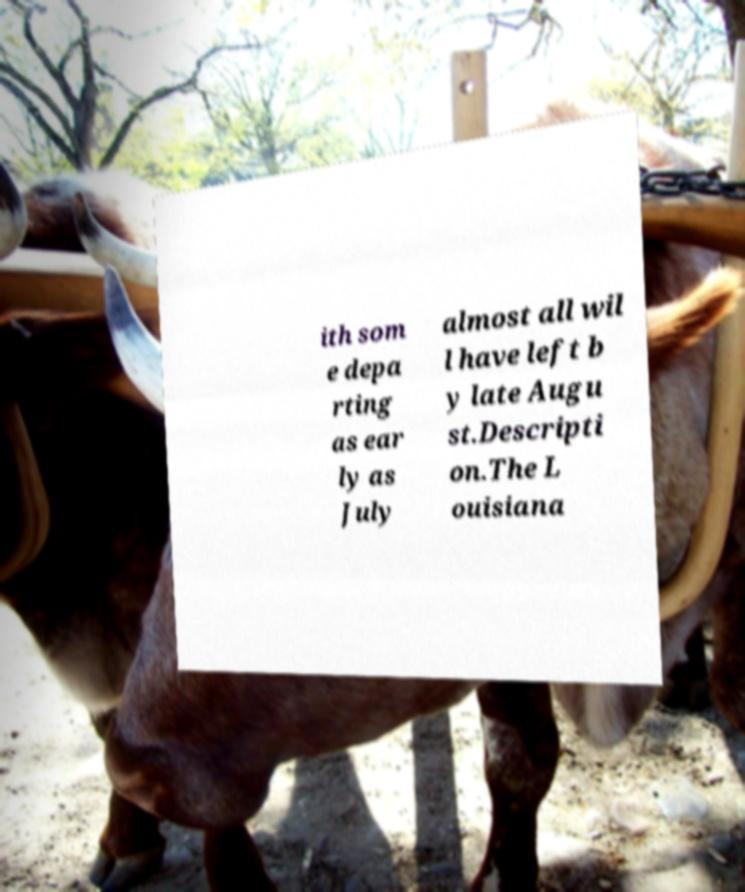Could you extract and type out the text from this image? ith som e depa rting as ear ly as July almost all wil l have left b y late Augu st.Descripti on.The L ouisiana 